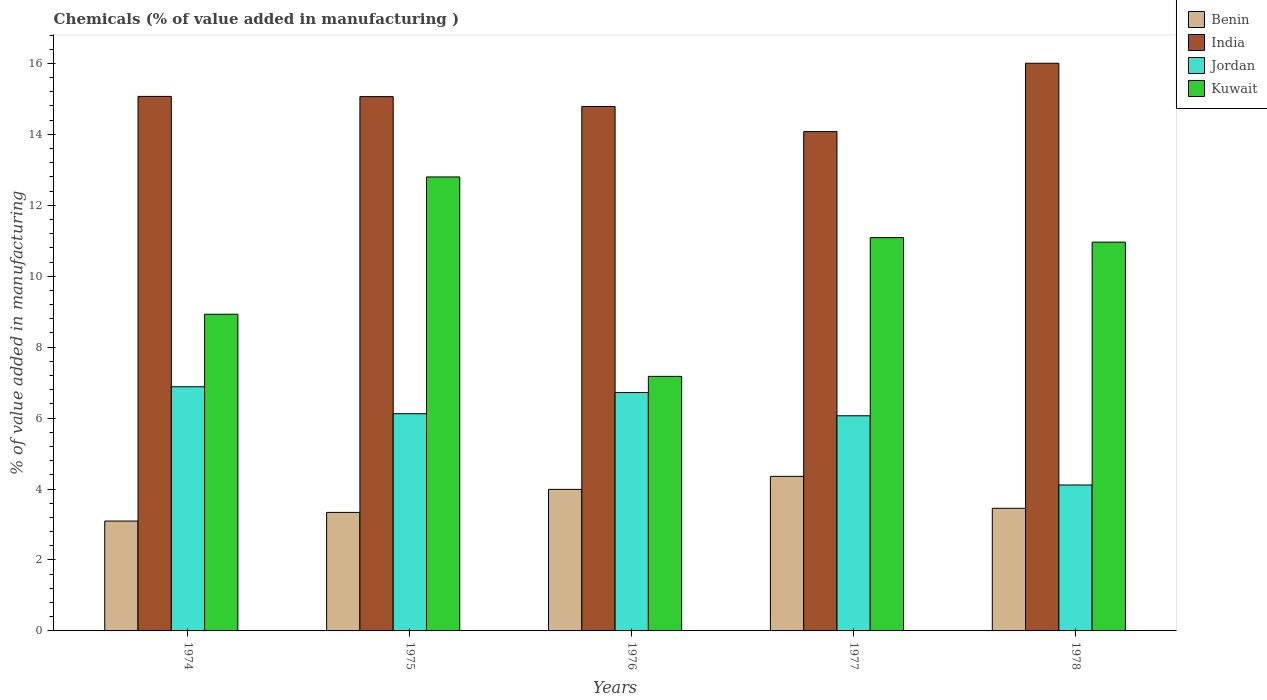How many different coloured bars are there?
Provide a short and direct response. 4. How many groups of bars are there?
Your answer should be very brief. 5. Are the number of bars on each tick of the X-axis equal?
Your answer should be very brief. Yes. What is the label of the 4th group of bars from the left?
Offer a very short reply. 1977. What is the value added in manufacturing chemicals in Benin in 1974?
Provide a short and direct response. 3.1. Across all years, what is the maximum value added in manufacturing chemicals in Kuwait?
Make the answer very short. 12.8. Across all years, what is the minimum value added in manufacturing chemicals in Kuwait?
Offer a terse response. 7.18. In which year was the value added in manufacturing chemicals in Kuwait maximum?
Offer a terse response. 1975. In which year was the value added in manufacturing chemicals in Jordan minimum?
Provide a succinct answer. 1978. What is the total value added in manufacturing chemicals in Benin in the graph?
Keep it short and to the point. 18.24. What is the difference between the value added in manufacturing chemicals in Jordan in 1975 and that in 1978?
Give a very brief answer. 2.01. What is the difference between the value added in manufacturing chemicals in India in 1975 and the value added in manufacturing chemicals in Jordan in 1978?
Ensure brevity in your answer.  10.95. What is the average value added in manufacturing chemicals in Kuwait per year?
Your response must be concise. 10.19. In the year 1978, what is the difference between the value added in manufacturing chemicals in Jordan and value added in manufacturing chemicals in Kuwait?
Ensure brevity in your answer.  -6.85. In how many years, is the value added in manufacturing chemicals in Jordan greater than 0.4 %?
Offer a very short reply. 5. What is the ratio of the value added in manufacturing chemicals in Kuwait in 1975 to that in 1978?
Offer a terse response. 1.17. Is the value added in manufacturing chemicals in Benin in 1976 less than that in 1977?
Your answer should be compact. Yes. What is the difference between the highest and the second highest value added in manufacturing chemicals in Benin?
Offer a very short reply. 0.37. What is the difference between the highest and the lowest value added in manufacturing chemicals in Kuwait?
Your answer should be compact. 5.62. Is it the case that in every year, the sum of the value added in manufacturing chemicals in India and value added in manufacturing chemicals in Kuwait is greater than the sum of value added in manufacturing chemicals in Benin and value added in manufacturing chemicals in Jordan?
Keep it short and to the point. No. What does the 4th bar from the left in 1975 represents?
Offer a terse response. Kuwait. What does the 2nd bar from the right in 1976 represents?
Offer a terse response. Jordan. Is it the case that in every year, the sum of the value added in manufacturing chemicals in Kuwait and value added in manufacturing chemicals in Jordan is greater than the value added in manufacturing chemicals in Benin?
Offer a terse response. Yes. How many bars are there?
Provide a succinct answer. 20. Are the values on the major ticks of Y-axis written in scientific E-notation?
Offer a very short reply. No. Does the graph contain any zero values?
Offer a terse response. No. Where does the legend appear in the graph?
Offer a very short reply. Top right. What is the title of the graph?
Provide a succinct answer. Chemicals (% of value added in manufacturing ). What is the label or title of the X-axis?
Offer a terse response. Years. What is the label or title of the Y-axis?
Your answer should be compact. % of value added in manufacturing. What is the % of value added in manufacturing of Benin in 1974?
Offer a very short reply. 3.1. What is the % of value added in manufacturing in India in 1974?
Give a very brief answer. 15.07. What is the % of value added in manufacturing of Jordan in 1974?
Ensure brevity in your answer.  6.88. What is the % of value added in manufacturing in Kuwait in 1974?
Provide a short and direct response. 8.93. What is the % of value added in manufacturing in Benin in 1975?
Your response must be concise. 3.34. What is the % of value added in manufacturing of India in 1975?
Keep it short and to the point. 15.06. What is the % of value added in manufacturing in Jordan in 1975?
Your answer should be compact. 6.12. What is the % of value added in manufacturing in Kuwait in 1975?
Provide a short and direct response. 12.8. What is the % of value added in manufacturing in Benin in 1976?
Provide a short and direct response. 3.99. What is the % of value added in manufacturing in India in 1976?
Keep it short and to the point. 14.79. What is the % of value added in manufacturing of Jordan in 1976?
Offer a very short reply. 6.72. What is the % of value added in manufacturing of Kuwait in 1976?
Your answer should be very brief. 7.18. What is the % of value added in manufacturing of Benin in 1977?
Provide a succinct answer. 4.36. What is the % of value added in manufacturing in India in 1977?
Your response must be concise. 14.08. What is the % of value added in manufacturing of Jordan in 1977?
Your answer should be very brief. 6.07. What is the % of value added in manufacturing in Kuwait in 1977?
Provide a succinct answer. 11.09. What is the % of value added in manufacturing of Benin in 1978?
Your response must be concise. 3.46. What is the % of value added in manufacturing of India in 1978?
Provide a short and direct response. 16. What is the % of value added in manufacturing in Jordan in 1978?
Give a very brief answer. 4.11. What is the % of value added in manufacturing in Kuwait in 1978?
Keep it short and to the point. 10.96. Across all years, what is the maximum % of value added in manufacturing in Benin?
Offer a very short reply. 4.36. Across all years, what is the maximum % of value added in manufacturing of India?
Keep it short and to the point. 16. Across all years, what is the maximum % of value added in manufacturing of Jordan?
Keep it short and to the point. 6.88. Across all years, what is the maximum % of value added in manufacturing of Kuwait?
Offer a terse response. 12.8. Across all years, what is the minimum % of value added in manufacturing in Benin?
Ensure brevity in your answer.  3.1. Across all years, what is the minimum % of value added in manufacturing of India?
Keep it short and to the point. 14.08. Across all years, what is the minimum % of value added in manufacturing in Jordan?
Give a very brief answer. 4.11. Across all years, what is the minimum % of value added in manufacturing of Kuwait?
Offer a terse response. 7.18. What is the total % of value added in manufacturing of Benin in the graph?
Make the answer very short. 18.24. What is the total % of value added in manufacturing in India in the graph?
Make the answer very short. 75. What is the total % of value added in manufacturing in Jordan in the graph?
Ensure brevity in your answer.  29.91. What is the total % of value added in manufacturing of Kuwait in the graph?
Offer a terse response. 50.95. What is the difference between the % of value added in manufacturing of Benin in 1974 and that in 1975?
Your answer should be very brief. -0.24. What is the difference between the % of value added in manufacturing of India in 1974 and that in 1975?
Your answer should be compact. 0.01. What is the difference between the % of value added in manufacturing in Jordan in 1974 and that in 1975?
Provide a succinct answer. 0.76. What is the difference between the % of value added in manufacturing of Kuwait in 1974 and that in 1975?
Make the answer very short. -3.87. What is the difference between the % of value added in manufacturing of Benin in 1974 and that in 1976?
Ensure brevity in your answer.  -0.89. What is the difference between the % of value added in manufacturing of India in 1974 and that in 1976?
Offer a terse response. 0.28. What is the difference between the % of value added in manufacturing in Jordan in 1974 and that in 1976?
Give a very brief answer. 0.16. What is the difference between the % of value added in manufacturing in Kuwait in 1974 and that in 1976?
Provide a short and direct response. 1.75. What is the difference between the % of value added in manufacturing in Benin in 1974 and that in 1977?
Your answer should be compact. -1.26. What is the difference between the % of value added in manufacturing in India in 1974 and that in 1977?
Your response must be concise. 0.99. What is the difference between the % of value added in manufacturing of Jordan in 1974 and that in 1977?
Make the answer very short. 0.82. What is the difference between the % of value added in manufacturing of Kuwait in 1974 and that in 1977?
Give a very brief answer. -2.16. What is the difference between the % of value added in manufacturing in Benin in 1974 and that in 1978?
Keep it short and to the point. -0.36. What is the difference between the % of value added in manufacturing in India in 1974 and that in 1978?
Your answer should be compact. -0.93. What is the difference between the % of value added in manufacturing in Jordan in 1974 and that in 1978?
Give a very brief answer. 2.77. What is the difference between the % of value added in manufacturing of Kuwait in 1974 and that in 1978?
Ensure brevity in your answer.  -2.03. What is the difference between the % of value added in manufacturing in Benin in 1975 and that in 1976?
Give a very brief answer. -0.65. What is the difference between the % of value added in manufacturing of India in 1975 and that in 1976?
Your answer should be very brief. 0.28. What is the difference between the % of value added in manufacturing in Jordan in 1975 and that in 1976?
Your answer should be compact. -0.6. What is the difference between the % of value added in manufacturing in Kuwait in 1975 and that in 1976?
Make the answer very short. 5.62. What is the difference between the % of value added in manufacturing in Benin in 1975 and that in 1977?
Keep it short and to the point. -1.02. What is the difference between the % of value added in manufacturing in India in 1975 and that in 1977?
Ensure brevity in your answer.  0.99. What is the difference between the % of value added in manufacturing of Jordan in 1975 and that in 1977?
Give a very brief answer. 0.06. What is the difference between the % of value added in manufacturing of Kuwait in 1975 and that in 1977?
Ensure brevity in your answer.  1.71. What is the difference between the % of value added in manufacturing in Benin in 1975 and that in 1978?
Give a very brief answer. -0.12. What is the difference between the % of value added in manufacturing of India in 1975 and that in 1978?
Ensure brevity in your answer.  -0.94. What is the difference between the % of value added in manufacturing of Jordan in 1975 and that in 1978?
Provide a short and direct response. 2.01. What is the difference between the % of value added in manufacturing of Kuwait in 1975 and that in 1978?
Keep it short and to the point. 1.84. What is the difference between the % of value added in manufacturing in Benin in 1976 and that in 1977?
Ensure brevity in your answer.  -0.37. What is the difference between the % of value added in manufacturing of India in 1976 and that in 1977?
Provide a succinct answer. 0.71. What is the difference between the % of value added in manufacturing of Jordan in 1976 and that in 1977?
Your answer should be compact. 0.66. What is the difference between the % of value added in manufacturing of Kuwait in 1976 and that in 1977?
Your response must be concise. -3.91. What is the difference between the % of value added in manufacturing of Benin in 1976 and that in 1978?
Give a very brief answer. 0.53. What is the difference between the % of value added in manufacturing in India in 1976 and that in 1978?
Ensure brevity in your answer.  -1.22. What is the difference between the % of value added in manufacturing in Jordan in 1976 and that in 1978?
Make the answer very short. 2.61. What is the difference between the % of value added in manufacturing of Kuwait in 1976 and that in 1978?
Give a very brief answer. -3.78. What is the difference between the % of value added in manufacturing in Benin in 1977 and that in 1978?
Make the answer very short. 0.9. What is the difference between the % of value added in manufacturing of India in 1977 and that in 1978?
Provide a succinct answer. -1.93. What is the difference between the % of value added in manufacturing in Jordan in 1977 and that in 1978?
Offer a terse response. 1.95. What is the difference between the % of value added in manufacturing of Kuwait in 1977 and that in 1978?
Give a very brief answer. 0.13. What is the difference between the % of value added in manufacturing of Benin in 1974 and the % of value added in manufacturing of India in 1975?
Give a very brief answer. -11.97. What is the difference between the % of value added in manufacturing in Benin in 1974 and the % of value added in manufacturing in Jordan in 1975?
Provide a short and direct response. -3.03. What is the difference between the % of value added in manufacturing in Benin in 1974 and the % of value added in manufacturing in Kuwait in 1975?
Your answer should be very brief. -9.7. What is the difference between the % of value added in manufacturing of India in 1974 and the % of value added in manufacturing of Jordan in 1975?
Make the answer very short. 8.95. What is the difference between the % of value added in manufacturing in India in 1974 and the % of value added in manufacturing in Kuwait in 1975?
Your answer should be compact. 2.27. What is the difference between the % of value added in manufacturing in Jordan in 1974 and the % of value added in manufacturing in Kuwait in 1975?
Ensure brevity in your answer.  -5.92. What is the difference between the % of value added in manufacturing of Benin in 1974 and the % of value added in manufacturing of India in 1976?
Keep it short and to the point. -11.69. What is the difference between the % of value added in manufacturing in Benin in 1974 and the % of value added in manufacturing in Jordan in 1976?
Offer a terse response. -3.62. What is the difference between the % of value added in manufacturing in Benin in 1974 and the % of value added in manufacturing in Kuwait in 1976?
Give a very brief answer. -4.08. What is the difference between the % of value added in manufacturing of India in 1974 and the % of value added in manufacturing of Jordan in 1976?
Your answer should be very brief. 8.35. What is the difference between the % of value added in manufacturing in India in 1974 and the % of value added in manufacturing in Kuwait in 1976?
Ensure brevity in your answer.  7.89. What is the difference between the % of value added in manufacturing in Jordan in 1974 and the % of value added in manufacturing in Kuwait in 1976?
Your answer should be compact. -0.29. What is the difference between the % of value added in manufacturing of Benin in 1974 and the % of value added in manufacturing of India in 1977?
Provide a succinct answer. -10.98. What is the difference between the % of value added in manufacturing of Benin in 1974 and the % of value added in manufacturing of Jordan in 1977?
Your answer should be compact. -2.97. What is the difference between the % of value added in manufacturing in Benin in 1974 and the % of value added in manufacturing in Kuwait in 1977?
Your answer should be compact. -7.99. What is the difference between the % of value added in manufacturing in India in 1974 and the % of value added in manufacturing in Jordan in 1977?
Offer a terse response. 9. What is the difference between the % of value added in manufacturing of India in 1974 and the % of value added in manufacturing of Kuwait in 1977?
Provide a succinct answer. 3.98. What is the difference between the % of value added in manufacturing in Jordan in 1974 and the % of value added in manufacturing in Kuwait in 1977?
Your answer should be very brief. -4.2. What is the difference between the % of value added in manufacturing in Benin in 1974 and the % of value added in manufacturing in India in 1978?
Offer a very short reply. -12.91. What is the difference between the % of value added in manufacturing of Benin in 1974 and the % of value added in manufacturing of Jordan in 1978?
Your answer should be compact. -1.02. What is the difference between the % of value added in manufacturing of Benin in 1974 and the % of value added in manufacturing of Kuwait in 1978?
Ensure brevity in your answer.  -7.86. What is the difference between the % of value added in manufacturing in India in 1974 and the % of value added in manufacturing in Jordan in 1978?
Provide a short and direct response. 10.96. What is the difference between the % of value added in manufacturing of India in 1974 and the % of value added in manufacturing of Kuwait in 1978?
Make the answer very short. 4.11. What is the difference between the % of value added in manufacturing in Jordan in 1974 and the % of value added in manufacturing in Kuwait in 1978?
Give a very brief answer. -4.08. What is the difference between the % of value added in manufacturing in Benin in 1975 and the % of value added in manufacturing in India in 1976?
Give a very brief answer. -11.44. What is the difference between the % of value added in manufacturing of Benin in 1975 and the % of value added in manufacturing of Jordan in 1976?
Give a very brief answer. -3.38. What is the difference between the % of value added in manufacturing of Benin in 1975 and the % of value added in manufacturing of Kuwait in 1976?
Keep it short and to the point. -3.83. What is the difference between the % of value added in manufacturing of India in 1975 and the % of value added in manufacturing of Jordan in 1976?
Keep it short and to the point. 8.34. What is the difference between the % of value added in manufacturing of India in 1975 and the % of value added in manufacturing of Kuwait in 1976?
Keep it short and to the point. 7.89. What is the difference between the % of value added in manufacturing in Jordan in 1975 and the % of value added in manufacturing in Kuwait in 1976?
Your response must be concise. -1.05. What is the difference between the % of value added in manufacturing in Benin in 1975 and the % of value added in manufacturing in India in 1977?
Provide a short and direct response. -10.74. What is the difference between the % of value added in manufacturing of Benin in 1975 and the % of value added in manufacturing of Jordan in 1977?
Ensure brevity in your answer.  -2.72. What is the difference between the % of value added in manufacturing of Benin in 1975 and the % of value added in manufacturing of Kuwait in 1977?
Your answer should be compact. -7.75. What is the difference between the % of value added in manufacturing in India in 1975 and the % of value added in manufacturing in Jordan in 1977?
Offer a terse response. 9. What is the difference between the % of value added in manufacturing of India in 1975 and the % of value added in manufacturing of Kuwait in 1977?
Provide a succinct answer. 3.98. What is the difference between the % of value added in manufacturing of Jordan in 1975 and the % of value added in manufacturing of Kuwait in 1977?
Your answer should be compact. -4.96. What is the difference between the % of value added in manufacturing in Benin in 1975 and the % of value added in manufacturing in India in 1978?
Give a very brief answer. -12.66. What is the difference between the % of value added in manufacturing in Benin in 1975 and the % of value added in manufacturing in Jordan in 1978?
Keep it short and to the point. -0.77. What is the difference between the % of value added in manufacturing of Benin in 1975 and the % of value added in manufacturing of Kuwait in 1978?
Provide a short and direct response. -7.62. What is the difference between the % of value added in manufacturing in India in 1975 and the % of value added in manufacturing in Jordan in 1978?
Ensure brevity in your answer.  10.95. What is the difference between the % of value added in manufacturing of India in 1975 and the % of value added in manufacturing of Kuwait in 1978?
Your response must be concise. 4.1. What is the difference between the % of value added in manufacturing in Jordan in 1975 and the % of value added in manufacturing in Kuwait in 1978?
Provide a short and direct response. -4.84. What is the difference between the % of value added in manufacturing in Benin in 1976 and the % of value added in manufacturing in India in 1977?
Your answer should be very brief. -10.09. What is the difference between the % of value added in manufacturing of Benin in 1976 and the % of value added in manufacturing of Jordan in 1977?
Provide a short and direct response. -2.08. What is the difference between the % of value added in manufacturing in Benin in 1976 and the % of value added in manufacturing in Kuwait in 1977?
Make the answer very short. -7.1. What is the difference between the % of value added in manufacturing of India in 1976 and the % of value added in manufacturing of Jordan in 1977?
Your answer should be very brief. 8.72. What is the difference between the % of value added in manufacturing in India in 1976 and the % of value added in manufacturing in Kuwait in 1977?
Provide a succinct answer. 3.7. What is the difference between the % of value added in manufacturing of Jordan in 1976 and the % of value added in manufacturing of Kuwait in 1977?
Provide a succinct answer. -4.37. What is the difference between the % of value added in manufacturing of Benin in 1976 and the % of value added in manufacturing of India in 1978?
Your answer should be very brief. -12.01. What is the difference between the % of value added in manufacturing in Benin in 1976 and the % of value added in manufacturing in Jordan in 1978?
Ensure brevity in your answer.  -0.12. What is the difference between the % of value added in manufacturing of Benin in 1976 and the % of value added in manufacturing of Kuwait in 1978?
Keep it short and to the point. -6.97. What is the difference between the % of value added in manufacturing of India in 1976 and the % of value added in manufacturing of Jordan in 1978?
Give a very brief answer. 10.67. What is the difference between the % of value added in manufacturing in India in 1976 and the % of value added in manufacturing in Kuwait in 1978?
Ensure brevity in your answer.  3.82. What is the difference between the % of value added in manufacturing in Jordan in 1976 and the % of value added in manufacturing in Kuwait in 1978?
Offer a terse response. -4.24. What is the difference between the % of value added in manufacturing of Benin in 1977 and the % of value added in manufacturing of India in 1978?
Give a very brief answer. -11.65. What is the difference between the % of value added in manufacturing of Benin in 1977 and the % of value added in manufacturing of Jordan in 1978?
Your answer should be compact. 0.24. What is the difference between the % of value added in manufacturing of Benin in 1977 and the % of value added in manufacturing of Kuwait in 1978?
Keep it short and to the point. -6.6. What is the difference between the % of value added in manufacturing in India in 1977 and the % of value added in manufacturing in Jordan in 1978?
Your answer should be compact. 9.96. What is the difference between the % of value added in manufacturing of India in 1977 and the % of value added in manufacturing of Kuwait in 1978?
Offer a very short reply. 3.12. What is the difference between the % of value added in manufacturing of Jordan in 1977 and the % of value added in manufacturing of Kuwait in 1978?
Offer a terse response. -4.9. What is the average % of value added in manufacturing of Benin per year?
Offer a terse response. 3.65. What is the average % of value added in manufacturing of India per year?
Keep it short and to the point. 15. What is the average % of value added in manufacturing in Jordan per year?
Give a very brief answer. 5.98. What is the average % of value added in manufacturing in Kuwait per year?
Provide a short and direct response. 10.19. In the year 1974, what is the difference between the % of value added in manufacturing in Benin and % of value added in manufacturing in India?
Your response must be concise. -11.97. In the year 1974, what is the difference between the % of value added in manufacturing of Benin and % of value added in manufacturing of Jordan?
Keep it short and to the point. -3.79. In the year 1974, what is the difference between the % of value added in manufacturing in Benin and % of value added in manufacturing in Kuwait?
Provide a succinct answer. -5.83. In the year 1974, what is the difference between the % of value added in manufacturing in India and % of value added in manufacturing in Jordan?
Provide a succinct answer. 8.19. In the year 1974, what is the difference between the % of value added in manufacturing in India and % of value added in manufacturing in Kuwait?
Your answer should be compact. 6.14. In the year 1974, what is the difference between the % of value added in manufacturing of Jordan and % of value added in manufacturing of Kuwait?
Provide a succinct answer. -2.04. In the year 1975, what is the difference between the % of value added in manufacturing in Benin and % of value added in manufacturing in India?
Provide a succinct answer. -11.72. In the year 1975, what is the difference between the % of value added in manufacturing in Benin and % of value added in manufacturing in Jordan?
Give a very brief answer. -2.78. In the year 1975, what is the difference between the % of value added in manufacturing in Benin and % of value added in manufacturing in Kuwait?
Give a very brief answer. -9.46. In the year 1975, what is the difference between the % of value added in manufacturing of India and % of value added in manufacturing of Jordan?
Give a very brief answer. 8.94. In the year 1975, what is the difference between the % of value added in manufacturing of India and % of value added in manufacturing of Kuwait?
Keep it short and to the point. 2.26. In the year 1975, what is the difference between the % of value added in manufacturing of Jordan and % of value added in manufacturing of Kuwait?
Your answer should be very brief. -6.68. In the year 1976, what is the difference between the % of value added in manufacturing in Benin and % of value added in manufacturing in India?
Make the answer very short. -10.8. In the year 1976, what is the difference between the % of value added in manufacturing of Benin and % of value added in manufacturing of Jordan?
Make the answer very short. -2.73. In the year 1976, what is the difference between the % of value added in manufacturing in Benin and % of value added in manufacturing in Kuwait?
Offer a very short reply. -3.19. In the year 1976, what is the difference between the % of value added in manufacturing of India and % of value added in manufacturing of Jordan?
Make the answer very short. 8.06. In the year 1976, what is the difference between the % of value added in manufacturing of India and % of value added in manufacturing of Kuwait?
Provide a succinct answer. 7.61. In the year 1976, what is the difference between the % of value added in manufacturing in Jordan and % of value added in manufacturing in Kuwait?
Offer a very short reply. -0.46. In the year 1977, what is the difference between the % of value added in manufacturing of Benin and % of value added in manufacturing of India?
Provide a short and direct response. -9.72. In the year 1977, what is the difference between the % of value added in manufacturing of Benin and % of value added in manufacturing of Jordan?
Your answer should be very brief. -1.71. In the year 1977, what is the difference between the % of value added in manufacturing of Benin and % of value added in manufacturing of Kuwait?
Keep it short and to the point. -6.73. In the year 1977, what is the difference between the % of value added in manufacturing of India and % of value added in manufacturing of Jordan?
Make the answer very short. 8.01. In the year 1977, what is the difference between the % of value added in manufacturing in India and % of value added in manufacturing in Kuwait?
Give a very brief answer. 2.99. In the year 1977, what is the difference between the % of value added in manufacturing in Jordan and % of value added in manufacturing in Kuwait?
Give a very brief answer. -5.02. In the year 1978, what is the difference between the % of value added in manufacturing in Benin and % of value added in manufacturing in India?
Your answer should be compact. -12.55. In the year 1978, what is the difference between the % of value added in manufacturing in Benin and % of value added in manufacturing in Jordan?
Ensure brevity in your answer.  -0.66. In the year 1978, what is the difference between the % of value added in manufacturing of Benin and % of value added in manufacturing of Kuwait?
Make the answer very short. -7.5. In the year 1978, what is the difference between the % of value added in manufacturing of India and % of value added in manufacturing of Jordan?
Provide a succinct answer. 11.89. In the year 1978, what is the difference between the % of value added in manufacturing of India and % of value added in manufacturing of Kuwait?
Offer a terse response. 5.04. In the year 1978, what is the difference between the % of value added in manufacturing of Jordan and % of value added in manufacturing of Kuwait?
Your answer should be compact. -6.85. What is the ratio of the % of value added in manufacturing of Benin in 1974 to that in 1975?
Keep it short and to the point. 0.93. What is the ratio of the % of value added in manufacturing in Jordan in 1974 to that in 1975?
Your response must be concise. 1.12. What is the ratio of the % of value added in manufacturing in Kuwait in 1974 to that in 1975?
Give a very brief answer. 0.7. What is the ratio of the % of value added in manufacturing of Benin in 1974 to that in 1976?
Make the answer very short. 0.78. What is the ratio of the % of value added in manufacturing of India in 1974 to that in 1976?
Make the answer very short. 1.02. What is the ratio of the % of value added in manufacturing in Jordan in 1974 to that in 1976?
Give a very brief answer. 1.02. What is the ratio of the % of value added in manufacturing of Kuwait in 1974 to that in 1976?
Provide a short and direct response. 1.24. What is the ratio of the % of value added in manufacturing in Benin in 1974 to that in 1977?
Make the answer very short. 0.71. What is the ratio of the % of value added in manufacturing of India in 1974 to that in 1977?
Offer a very short reply. 1.07. What is the ratio of the % of value added in manufacturing in Jordan in 1974 to that in 1977?
Your response must be concise. 1.13. What is the ratio of the % of value added in manufacturing in Kuwait in 1974 to that in 1977?
Ensure brevity in your answer.  0.81. What is the ratio of the % of value added in manufacturing of Benin in 1974 to that in 1978?
Provide a succinct answer. 0.9. What is the ratio of the % of value added in manufacturing in India in 1974 to that in 1978?
Ensure brevity in your answer.  0.94. What is the ratio of the % of value added in manufacturing in Jordan in 1974 to that in 1978?
Offer a very short reply. 1.67. What is the ratio of the % of value added in manufacturing of Kuwait in 1974 to that in 1978?
Keep it short and to the point. 0.81. What is the ratio of the % of value added in manufacturing in Benin in 1975 to that in 1976?
Offer a terse response. 0.84. What is the ratio of the % of value added in manufacturing of India in 1975 to that in 1976?
Provide a short and direct response. 1.02. What is the ratio of the % of value added in manufacturing in Jordan in 1975 to that in 1976?
Provide a short and direct response. 0.91. What is the ratio of the % of value added in manufacturing in Kuwait in 1975 to that in 1976?
Give a very brief answer. 1.78. What is the ratio of the % of value added in manufacturing of Benin in 1975 to that in 1977?
Provide a succinct answer. 0.77. What is the ratio of the % of value added in manufacturing of India in 1975 to that in 1977?
Give a very brief answer. 1.07. What is the ratio of the % of value added in manufacturing in Jordan in 1975 to that in 1977?
Your response must be concise. 1.01. What is the ratio of the % of value added in manufacturing of Kuwait in 1975 to that in 1977?
Offer a very short reply. 1.15. What is the ratio of the % of value added in manufacturing in Benin in 1975 to that in 1978?
Provide a succinct answer. 0.97. What is the ratio of the % of value added in manufacturing in Jordan in 1975 to that in 1978?
Keep it short and to the point. 1.49. What is the ratio of the % of value added in manufacturing of Kuwait in 1975 to that in 1978?
Your answer should be very brief. 1.17. What is the ratio of the % of value added in manufacturing of Benin in 1976 to that in 1977?
Your response must be concise. 0.92. What is the ratio of the % of value added in manufacturing of India in 1976 to that in 1977?
Ensure brevity in your answer.  1.05. What is the ratio of the % of value added in manufacturing in Jordan in 1976 to that in 1977?
Give a very brief answer. 1.11. What is the ratio of the % of value added in manufacturing in Kuwait in 1976 to that in 1977?
Provide a short and direct response. 0.65. What is the ratio of the % of value added in manufacturing of Benin in 1976 to that in 1978?
Your answer should be compact. 1.15. What is the ratio of the % of value added in manufacturing in India in 1976 to that in 1978?
Make the answer very short. 0.92. What is the ratio of the % of value added in manufacturing in Jordan in 1976 to that in 1978?
Make the answer very short. 1.63. What is the ratio of the % of value added in manufacturing in Kuwait in 1976 to that in 1978?
Your answer should be very brief. 0.65. What is the ratio of the % of value added in manufacturing of Benin in 1977 to that in 1978?
Ensure brevity in your answer.  1.26. What is the ratio of the % of value added in manufacturing of India in 1977 to that in 1978?
Ensure brevity in your answer.  0.88. What is the ratio of the % of value added in manufacturing of Jordan in 1977 to that in 1978?
Offer a terse response. 1.47. What is the ratio of the % of value added in manufacturing in Kuwait in 1977 to that in 1978?
Provide a succinct answer. 1.01. What is the difference between the highest and the second highest % of value added in manufacturing of Benin?
Make the answer very short. 0.37. What is the difference between the highest and the second highest % of value added in manufacturing of India?
Your response must be concise. 0.93. What is the difference between the highest and the second highest % of value added in manufacturing in Jordan?
Offer a very short reply. 0.16. What is the difference between the highest and the second highest % of value added in manufacturing in Kuwait?
Make the answer very short. 1.71. What is the difference between the highest and the lowest % of value added in manufacturing of Benin?
Offer a terse response. 1.26. What is the difference between the highest and the lowest % of value added in manufacturing of India?
Make the answer very short. 1.93. What is the difference between the highest and the lowest % of value added in manufacturing in Jordan?
Your response must be concise. 2.77. What is the difference between the highest and the lowest % of value added in manufacturing of Kuwait?
Your response must be concise. 5.62. 